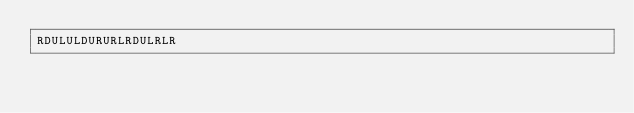<code> <loc_0><loc_0><loc_500><loc_500><_Python_>RDULULDURURLRDULRLR</code> 